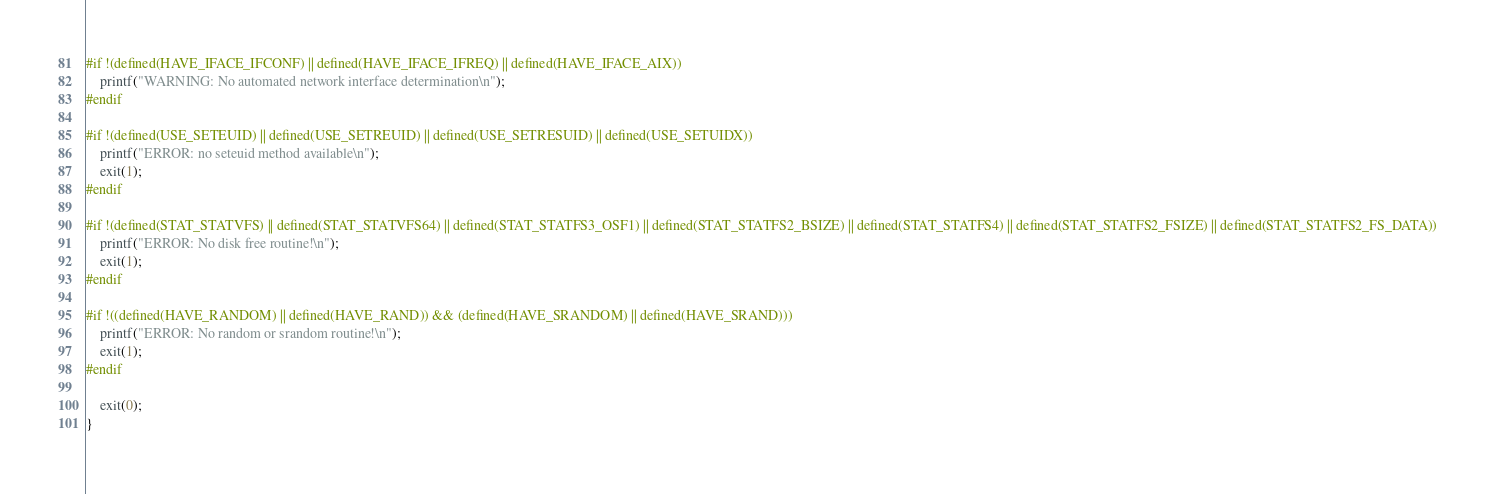Convert code to text. <code><loc_0><loc_0><loc_500><loc_500><_C_>
#if !(defined(HAVE_IFACE_IFCONF) || defined(HAVE_IFACE_IFREQ) || defined(HAVE_IFACE_AIX))
	printf("WARNING: No automated network interface determination\n");
#endif

#if !(defined(USE_SETEUID) || defined(USE_SETREUID) || defined(USE_SETRESUID) || defined(USE_SETUIDX))
	printf("ERROR: no seteuid method available\n");
	exit(1);
#endif

#if !(defined(STAT_STATVFS) || defined(STAT_STATVFS64) || defined(STAT_STATFS3_OSF1) || defined(STAT_STATFS2_BSIZE) || defined(STAT_STATFS4) || defined(STAT_STATFS2_FSIZE) || defined(STAT_STATFS2_FS_DATA))
	printf("ERROR: No disk free routine!\n");
	exit(1);
#endif

#if !((defined(HAVE_RANDOM) || defined(HAVE_RAND)) && (defined(HAVE_SRANDOM) || defined(HAVE_SRAND)))
    printf("ERROR: No random or srandom routine!\n");
    exit(1);
#endif

	exit(0);
}
</code> 